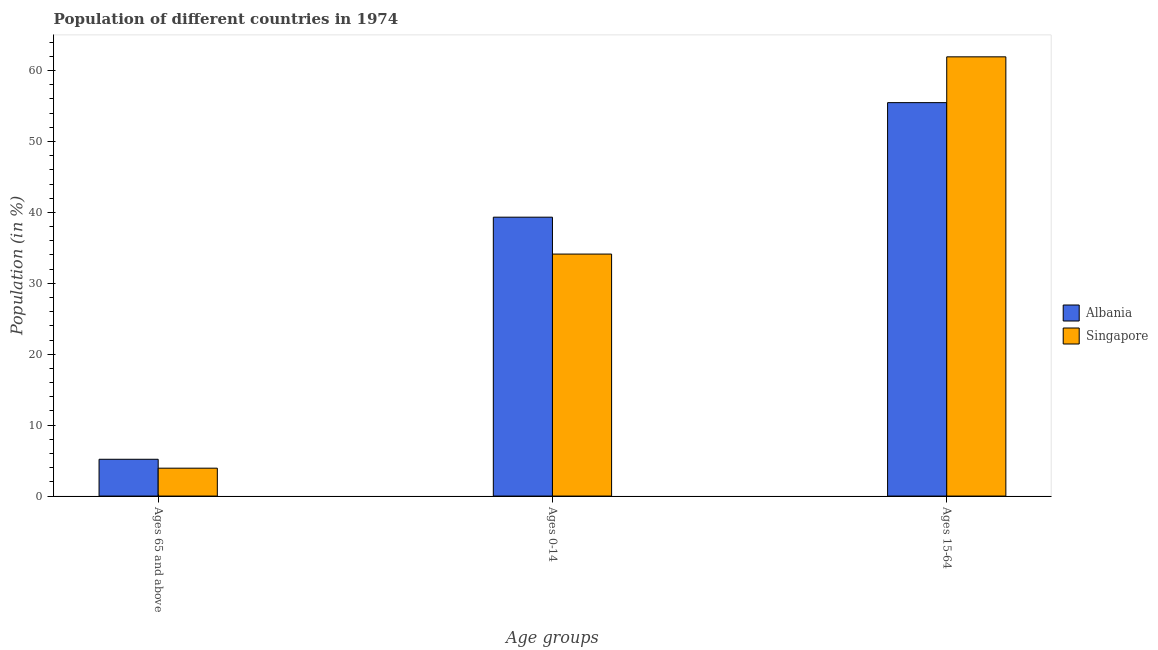How many different coloured bars are there?
Make the answer very short. 2. Are the number of bars on each tick of the X-axis equal?
Offer a very short reply. Yes. How many bars are there on the 3rd tick from the left?
Make the answer very short. 2. How many bars are there on the 1st tick from the right?
Your response must be concise. 2. What is the label of the 3rd group of bars from the left?
Your answer should be compact. Ages 15-64. What is the percentage of population within the age-group of 65 and above in Singapore?
Make the answer very short. 3.93. Across all countries, what is the maximum percentage of population within the age-group 15-64?
Your answer should be very brief. 61.94. Across all countries, what is the minimum percentage of population within the age-group 0-14?
Offer a terse response. 34.13. In which country was the percentage of population within the age-group of 65 and above maximum?
Provide a succinct answer. Albania. In which country was the percentage of population within the age-group 0-14 minimum?
Provide a succinct answer. Singapore. What is the total percentage of population within the age-group of 65 and above in the graph?
Keep it short and to the point. 9.12. What is the difference between the percentage of population within the age-group 0-14 in Singapore and that in Albania?
Your answer should be compact. -5.2. What is the difference between the percentage of population within the age-group 15-64 in Albania and the percentage of population within the age-group of 65 and above in Singapore?
Ensure brevity in your answer.  51.55. What is the average percentage of population within the age-group 0-14 per country?
Offer a very short reply. 36.73. What is the difference between the percentage of population within the age-group 15-64 and percentage of population within the age-group of 65 and above in Albania?
Your answer should be compact. 50.29. What is the ratio of the percentage of population within the age-group of 65 and above in Albania to that in Singapore?
Your answer should be very brief. 1.32. Is the percentage of population within the age-group 0-14 in Albania less than that in Singapore?
Keep it short and to the point. No. What is the difference between the highest and the second highest percentage of population within the age-group 15-64?
Make the answer very short. 6.46. What is the difference between the highest and the lowest percentage of population within the age-group of 65 and above?
Offer a terse response. 1.26. In how many countries, is the percentage of population within the age-group 15-64 greater than the average percentage of population within the age-group 15-64 taken over all countries?
Your answer should be very brief. 1. What does the 2nd bar from the left in Ages 65 and above represents?
Keep it short and to the point. Singapore. What does the 2nd bar from the right in Ages 0-14 represents?
Your answer should be very brief. Albania. Is it the case that in every country, the sum of the percentage of population within the age-group of 65 and above and percentage of population within the age-group 0-14 is greater than the percentage of population within the age-group 15-64?
Your answer should be very brief. No. How many bars are there?
Ensure brevity in your answer.  6. Are all the bars in the graph horizontal?
Offer a terse response. No. How many countries are there in the graph?
Ensure brevity in your answer.  2. Are the values on the major ticks of Y-axis written in scientific E-notation?
Provide a short and direct response. No. How many legend labels are there?
Ensure brevity in your answer.  2. How are the legend labels stacked?
Offer a very short reply. Vertical. What is the title of the graph?
Your response must be concise. Population of different countries in 1974. Does "Greece" appear as one of the legend labels in the graph?
Provide a succinct answer. No. What is the label or title of the X-axis?
Your response must be concise. Age groups. What is the Population (in %) in Albania in Ages 65 and above?
Give a very brief answer. 5.19. What is the Population (in %) of Singapore in Ages 65 and above?
Your answer should be very brief. 3.93. What is the Population (in %) in Albania in Ages 0-14?
Your response must be concise. 39.33. What is the Population (in %) of Singapore in Ages 0-14?
Your response must be concise. 34.13. What is the Population (in %) in Albania in Ages 15-64?
Your answer should be compact. 55.48. What is the Population (in %) in Singapore in Ages 15-64?
Offer a terse response. 61.94. Across all Age groups, what is the maximum Population (in %) in Albania?
Your response must be concise. 55.48. Across all Age groups, what is the maximum Population (in %) in Singapore?
Provide a succinct answer. 61.94. Across all Age groups, what is the minimum Population (in %) in Albania?
Ensure brevity in your answer.  5.19. Across all Age groups, what is the minimum Population (in %) of Singapore?
Keep it short and to the point. 3.93. What is the total Population (in %) in Singapore in the graph?
Make the answer very short. 100. What is the difference between the Population (in %) of Albania in Ages 65 and above and that in Ages 0-14?
Keep it short and to the point. -34.14. What is the difference between the Population (in %) of Singapore in Ages 65 and above and that in Ages 0-14?
Provide a short and direct response. -30.2. What is the difference between the Population (in %) in Albania in Ages 65 and above and that in Ages 15-64?
Provide a short and direct response. -50.29. What is the difference between the Population (in %) in Singapore in Ages 65 and above and that in Ages 15-64?
Make the answer very short. -58.01. What is the difference between the Population (in %) of Albania in Ages 0-14 and that in Ages 15-64?
Your response must be concise. -16.15. What is the difference between the Population (in %) of Singapore in Ages 0-14 and that in Ages 15-64?
Keep it short and to the point. -27.81. What is the difference between the Population (in %) of Albania in Ages 65 and above and the Population (in %) of Singapore in Ages 0-14?
Your answer should be compact. -28.94. What is the difference between the Population (in %) in Albania in Ages 65 and above and the Population (in %) in Singapore in Ages 15-64?
Your answer should be very brief. -56.75. What is the difference between the Population (in %) of Albania in Ages 0-14 and the Population (in %) of Singapore in Ages 15-64?
Provide a short and direct response. -22.61. What is the average Population (in %) in Albania per Age groups?
Provide a succinct answer. 33.33. What is the average Population (in %) in Singapore per Age groups?
Ensure brevity in your answer.  33.33. What is the difference between the Population (in %) in Albania and Population (in %) in Singapore in Ages 65 and above?
Your answer should be compact. 1.26. What is the difference between the Population (in %) of Albania and Population (in %) of Singapore in Ages 0-14?
Your answer should be very brief. 5.2. What is the difference between the Population (in %) of Albania and Population (in %) of Singapore in Ages 15-64?
Your answer should be very brief. -6.46. What is the ratio of the Population (in %) of Albania in Ages 65 and above to that in Ages 0-14?
Your response must be concise. 0.13. What is the ratio of the Population (in %) in Singapore in Ages 65 and above to that in Ages 0-14?
Provide a short and direct response. 0.12. What is the ratio of the Population (in %) of Albania in Ages 65 and above to that in Ages 15-64?
Ensure brevity in your answer.  0.09. What is the ratio of the Population (in %) of Singapore in Ages 65 and above to that in Ages 15-64?
Ensure brevity in your answer.  0.06. What is the ratio of the Population (in %) in Albania in Ages 0-14 to that in Ages 15-64?
Your response must be concise. 0.71. What is the ratio of the Population (in %) in Singapore in Ages 0-14 to that in Ages 15-64?
Provide a short and direct response. 0.55. What is the difference between the highest and the second highest Population (in %) in Albania?
Make the answer very short. 16.15. What is the difference between the highest and the second highest Population (in %) of Singapore?
Give a very brief answer. 27.81. What is the difference between the highest and the lowest Population (in %) of Albania?
Ensure brevity in your answer.  50.29. What is the difference between the highest and the lowest Population (in %) in Singapore?
Make the answer very short. 58.01. 